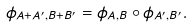<formula> <loc_0><loc_0><loc_500><loc_500>\phi _ { A + A ^ { \prime } , B + B ^ { \prime } } = \phi _ { A , B } \circ \phi _ { A ^ { \prime } , B ^ { \prime } } .</formula> 